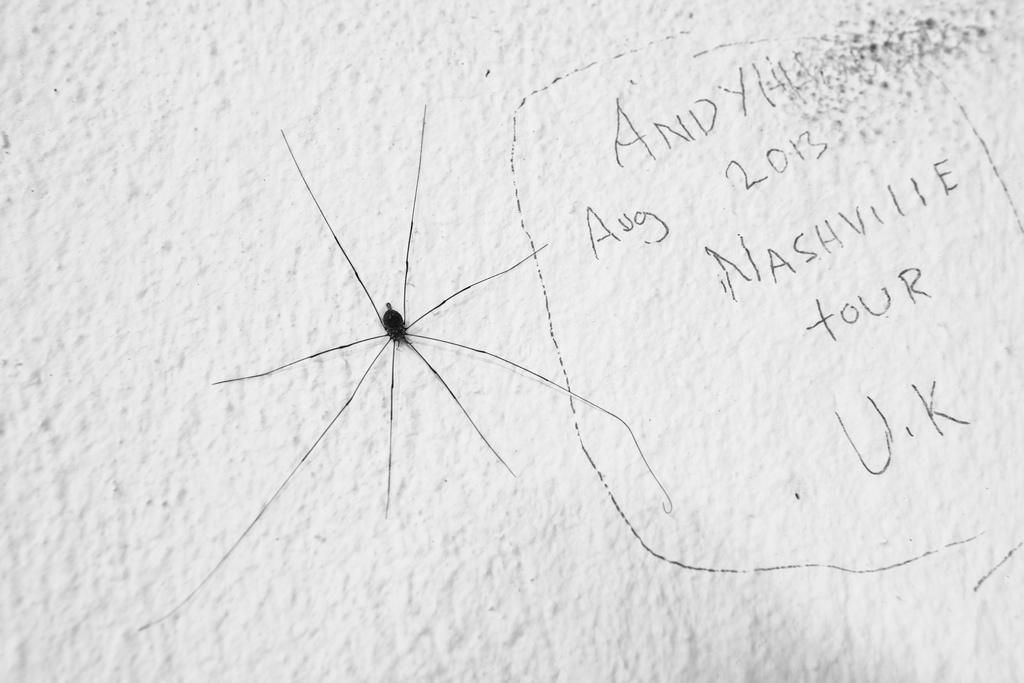What type of animal can be seen in the image? There is a small black spider in the image. What is the color of the wall where the spider is located? The spider is on a white wall. How many rabbits are present in the image? There are no rabbits present in the image; it features a small black spider on a white wall. What type of committee can be seen in the image? There is no committee present in the image; it features a small black spider on a white wall. 